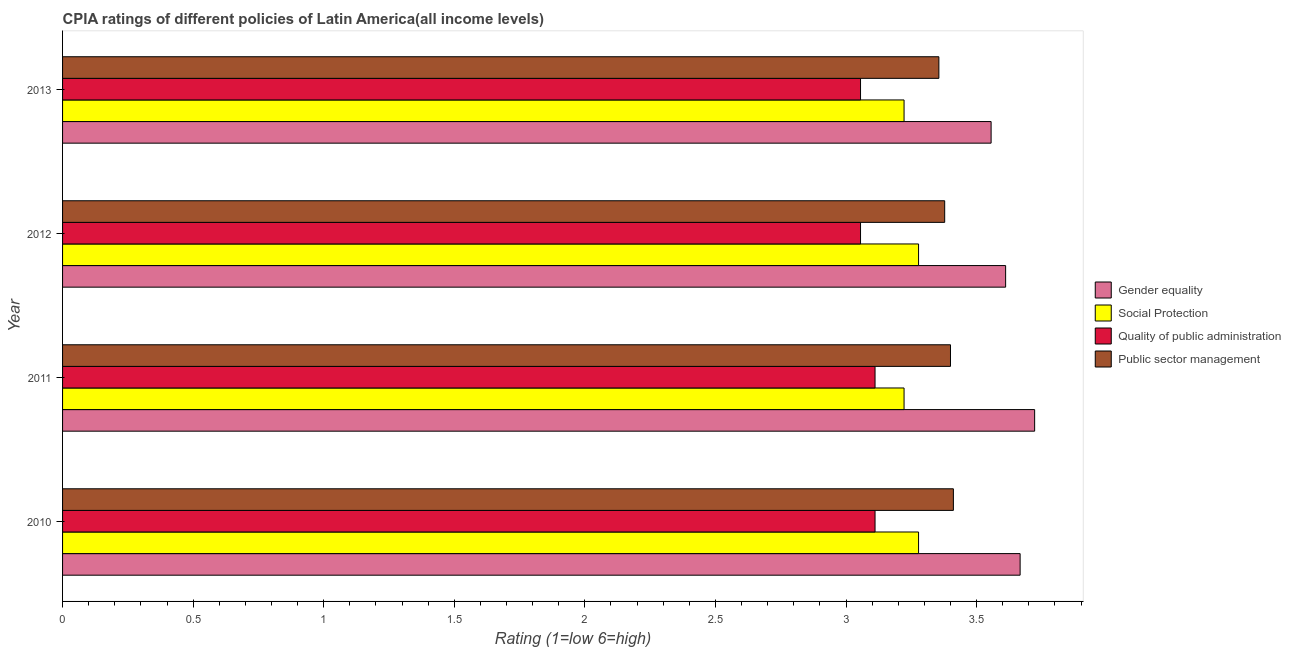How many bars are there on the 3rd tick from the bottom?
Ensure brevity in your answer.  4. What is the cpia rating of social protection in 2012?
Provide a short and direct response. 3.28. Across all years, what is the maximum cpia rating of quality of public administration?
Make the answer very short. 3.11. Across all years, what is the minimum cpia rating of gender equality?
Make the answer very short. 3.56. What is the total cpia rating of public sector management in the graph?
Ensure brevity in your answer.  13.54. What is the difference between the cpia rating of gender equality in 2012 and that in 2013?
Offer a terse response. 0.06. What is the average cpia rating of public sector management per year?
Your answer should be very brief. 3.39. In the year 2012, what is the difference between the cpia rating of quality of public administration and cpia rating of public sector management?
Provide a short and direct response. -0.32. Is the difference between the cpia rating of gender equality in 2010 and 2012 greater than the difference between the cpia rating of social protection in 2010 and 2012?
Ensure brevity in your answer.  Yes. What is the difference between the highest and the lowest cpia rating of social protection?
Make the answer very short. 0.06. Is it the case that in every year, the sum of the cpia rating of social protection and cpia rating of gender equality is greater than the sum of cpia rating of public sector management and cpia rating of quality of public administration?
Give a very brief answer. Yes. What does the 3rd bar from the top in 2013 represents?
Make the answer very short. Social Protection. What does the 1st bar from the bottom in 2013 represents?
Make the answer very short. Gender equality. Is it the case that in every year, the sum of the cpia rating of gender equality and cpia rating of social protection is greater than the cpia rating of quality of public administration?
Give a very brief answer. Yes. Are all the bars in the graph horizontal?
Make the answer very short. Yes. How many years are there in the graph?
Keep it short and to the point. 4. What is the difference between two consecutive major ticks on the X-axis?
Your answer should be very brief. 0.5. Does the graph contain any zero values?
Provide a succinct answer. No. What is the title of the graph?
Your answer should be very brief. CPIA ratings of different policies of Latin America(all income levels). What is the Rating (1=low 6=high) of Gender equality in 2010?
Your answer should be compact. 3.67. What is the Rating (1=low 6=high) in Social Protection in 2010?
Offer a very short reply. 3.28. What is the Rating (1=low 6=high) in Quality of public administration in 2010?
Offer a terse response. 3.11. What is the Rating (1=low 6=high) of Public sector management in 2010?
Make the answer very short. 3.41. What is the Rating (1=low 6=high) in Gender equality in 2011?
Your response must be concise. 3.72. What is the Rating (1=low 6=high) of Social Protection in 2011?
Your answer should be very brief. 3.22. What is the Rating (1=low 6=high) of Quality of public administration in 2011?
Provide a succinct answer. 3.11. What is the Rating (1=low 6=high) in Public sector management in 2011?
Provide a succinct answer. 3.4. What is the Rating (1=low 6=high) of Gender equality in 2012?
Keep it short and to the point. 3.61. What is the Rating (1=low 6=high) in Social Protection in 2012?
Offer a terse response. 3.28. What is the Rating (1=low 6=high) in Quality of public administration in 2012?
Provide a succinct answer. 3.06. What is the Rating (1=low 6=high) in Public sector management in 2012?
Your response must be concise. 3.38. What is the Rating (1=low 6=high) of Gender equality in 2013?
Ensure brevity in your answer.  3.56. What is the Rating (1=low 6=high) in Social Protection in 2013?
Give a very brief answer. 3.22. What is the Rating (1=low 6=high) in Quality of public administration in 2013?
Offer a very short reply. 3.06. What is the Rating (1=low 6=high) of Public sector management in 2013?
Provide a succinct answer. 3.36. Across all years, what is the maximum Rating (1=low 6=high) of Gender equality?
Your answer should be very brief. 3.72. Across all years, what is the maximum Rating (1=low 6=high) of Social Protection?
Offer a terse response. 3.28. Across all years, what is the maximum Rating (1=low 6=high) in Quality of public administration?
Your answer should be very brief. 3.11. Across all years, what is the maximum Rating (1=low 6=high) in Public sector management?
Give a very brief answer. 3.41. Across all years, what is the minimum Rating (1=low 6=high) of Gender equality?
Ensure brevity in your answer.  3.56. Across all years, what is the minimum Rating (1=low 6=high) of Social Protection?
Your response must be concise. 3.22. Across all years, what is the minimum Rating (1=low 6=high) of Quality of public administration?
Your answer should be compact. 3.06. Across all years, what is the minimum Rating (1=low 6=high) in Public sector management?
Your response must be concise. 3.36. What is the total Rating (1=low 6=high) in Gender equality in the graph?
Provide a succinct answer. 14.56. What is the total Rating (1=low 6=high) in Quality of public administration in the graph?
Your response must be concise. 12.33. What is the total Rating (1=low 6=high) in Public sector management in the graph?
Give a very brief answer. 13.54. What is the difference between the Rating (1=low 6=high) in Gender equality in 2010 and that in 2011?
Ensure brevity in your answer.  -0.06. What is the difference between the Rating (1=low 6=high) of Social Protection in 2010 and that in 2011?
Your answer should be compact. 0.06. What is the difference between the Rating (1=low 6=high) of Public sector management in 2010 and that in 2011?
Your answer should be compact. 0.01. What is the difference between the Rating (1=low 6=high) in Gender equality in 2010 and that in 2012?
Your answer should be very brief. 0.06. What is the difference between the Rating (1=low 6=high) of Social Protection in 2010 and that in 2012?
Your answer should be very brief. 0. What is the difference between the Rating (1=low 6=high) of Quality of public administration in 2010 and that in 2012?
Provide a short and direct response. 0.06. What is the difference between the Rating (1=low 6=high) of Public sector management in 2010 and that in 2012?
Your response must be concise. 0.03. What is the difference between the Rating (1=low 6=high) of Social Protection in 2010 and that in 2013?
Your answer should be compact. 0.06. What is the difference between the Rating (1=low 6=high) in Quality of public administration in 2010 and that in 2013?
Ensure brevity in your answer.  0.06. What is the difference between the Rating (1=low 6=high) in Public sector management in 2010 and that in 2013?
Ensure brevity in your answer.  0.06. What is the difference between the Rating (1=low 6=high) of Gender equality in 2011 and that in 2012?
Make the answer very short. 0.11. What is the difference between the Rating (1=low 6=high) in Social Protection in 2011 and that in 2012?
Offer a terse response. -0.06. What is the difference between the Rating (1=low 6=high) of Quality of public administration in 2011 and that in 2012?
Your answer should be compact. 0.06. What is the difference between the Rating (1=low 6=high) in Public sector management in 2011 and that in 2012?
Offer a terse response. 0.02. What is the difference between the Rating (1=low 6=high) of Social Protection in 2011 and that in 2013?
Make the answer very short. 0. What is the difference between the Rating (1=low 6=high) in Quality of public administration in 2011 and that in 2013?
Make the answer very short. 0.06. What is the difference between the Rating (1=low 6=high) of Public sector management in 2011 and that in 2013?
Offer a terse response. 0.04. What is the difference between the Rating (1=low 6=high) of Gender equality in 2012 and that in 2013?
Provide a short and direct response. 0.06. What is the difference between the Rating (1=low 6=high) of Social Protection in 2012 and that in 2013?
Offer a very short reply. 0.06. What is the difference between the Rating (1=low 6=high) of Public sector management in 2012 and that in 2013?
Your answer should be compact. 0.02. What is the difference between the Rating (1=low 6=high) of Gender equality in 2010 and the Rating (1=low 6=high) of Social Protection in 2011?
Provide a succinct answer. 0.44. What is the difference between the Rating (1=low 6=high) of Gender equality in 2010 and the Rating (1=low 6=high) of Quality of public administration in 2011?
Offer a very short reply. 0.56. What is the difference between the Rating (1=low 6=high) of Gender equality in 2010 and the Rating (1=low 6=high) of Public sector management in 2011?
Your answer should be very brief. 0.27. What is the difference between the Rating (1=low 6=high) of Social Protection in 2010 and the Rating (1=low 6=high) of Public sector management in 2011?
Offer a very short reply. -0.12. What is the difference between the Rating (1=low 6=high) of Quality of public administration in 2010 and the Rating (1=low 6=high) of Public sector management in 2011?
Offer a very short reply. -0.29. What is the difference between the Rating (1=low 6=high) of Gender equality in 2010 and the Rating (1=low 6=high) of Social Protection in 2012?
Your answer should be compact. 0.39. What is the difference between the Rating (1=low 6=high) in Gender equality in 2010 and the Rating (1=low 6=high) in Quality of public administration in 2012?
Your response must be concise. 0.61. What is the difference between the Rating (1=low 6=high) of Gender equality in 2010 and the Rating (1=low 6=high) of Public sector management in 2012?
Provide a short and direct response. 0.29. What is the difference between the Rating (1=low 6=high) of Social Protection in 2010 and the Rating (1=low 6=high) of Quality of public administration in 2012?
Your response must be concise. 0.22. What is the difference between the Rating (1=low 6=high) of Social Protection in 2010 and the Rating (1=low 6=high) of Public sector management in 2012?
Make the answer very short. -0.1. What is the difference between the Rating (1=low 6=high) in Quality of public administration in 2010 and the Rating (1=low 6=high) in Public sector management in 2012?
Provide a succinct answer. -0.27. What is the difference between the Rating (1=low 6=high) in Gender equality in 2010 and the Rating (1=low 6=high) in Social Protection in 2013?
Your answer should be very brief. 0.44. What is the difference between the Rating (1=low 6=high) in Gender equality in 2010 and the Rating (1=low 6=high) in Quality of public administration in 2013?
Your answer should be compact. 0.61. What is the difference between the Rating (1=low 6=high) of Gender equality in 2010 and the Rating (1=low 6=high) of Public sector management in 2013?
Keep it short and to the point. 0.31. What is the difference between the Rating (1=low 6=high) in Social Protection in 2010 and the Rating (1=low 6=high) in Quality of public administration in 2013?
Offer a very short reply. 0.22. What is the difference between the Rating (1=low 6=high) in Social Protection in 2010 and the Rating (1=low 6=high) in Public sector management in 2013?
Provide a short and direct response. -0.08. What is the difference between the Rating (1=low 6=high) in Quality of public administration in 2010 and the Rating (1=low 6=high) in Public sector management in 2013?
Provide a succinct answer. -0.24. What is the difference between the Rating (1=low 6=high) in Gender equality in 2011 and the Rating (1=low 6=high) in Social Protection in 2012?
Provide a short and direct response. 0.44. What is the difference between the Rating (1=low 6=high) in Gender equality in 2011 and the Rating (1=low 6=high) in Quality of public administration in 2012?
Offer a very short reply. 0.67. What is the difference between the Rating (1=low 6=high) of Gender equality in 2011 and the Rating (1=low 6=high) of Public sector management in 2012?
Give a very brief answer. 0.34. What is the difference between the Rating (1=low 6=high) of Social Protection in 2011 and the Rating (1=low 6=high) of Quality of public administration in 2012?
Provide a short and direct response. 0.17. What is the difference between the Rating (1=low 6=high) in Social Protection in 2011 and the Rating (1=low 6=high) in Public sector management in 2012?
Ensure brevity in your answer.  -0.16. What is the difference between the Rating (1=low 6=high) in Quality of public administration in 2011 and the Rating (1=low 6=high) in Public sector management in 2012?
Provide a short and direct response. -0.27. What is the difference between the Rating (1=low 6=high) of Gender equality in 2011 and the Rating (1=low 6=high) of Social Protection in 2013?
Offer a terse response. 0.5. What is the difference between the Rating (1=low 6=high) of Gender equality in 2011 and the Rating (1=low 6=high) of Public sector management in 2013?
Offer a very short reply. 0.37. What is the difference between the Rating (1=low 6=high) of Social Protection in 2011 and the Rating (1=low 6=high) of Quality of public administration in 2013?
Ensure brevity in your answer.  0.17. What is the difference between the Rating (1=low 6=high) of Social Protection in 2011 and the Rating (1=low 6=high) of Public sector management in 2013?
Provide a short and direct response. -0.13. What is the difference between the Rating (1=low 6=high) in Quality of public administration in 2011 and the Rating (1=low 6=high) in Public sector management in 2013?
Ensure brevity in your answer.  -0.24. What is the difference between the Rating (1=low 6=high) in Gender equality in 2012 and the Rating (1=low 6=high) in Social Protection in 2013?
Keep it short and to the point. 0.39. What is the difference between the Rating (1=low 6=high) of Gender equality in 2012 and the Rating (1=low 6=high) of Quality of public administration in 2013?
Make the answer very short. 0.56. What is the difference between the Rating (1=low 6=high) in Gender equality in 2012 and the Rating (1=low 6=high) in Public sector management in 2013?
Your answer should be very brief. 0.26. What is the difference between the Rating (1=low 6=high) of Social Protection in 2012 and the Rating (1=low 6=high) of Quality of public administration in 2013?
Provide a short and direct response. 0.22. What is the difference between the Rating (1=low 6=high) of Social Protection in 2012 and the Rating (1=low 6=high) of Public sector management in 2013?
Your answer should be very brief. -0.08. What is the difference between the Rating (1=low 6=high) of Quality of public administration in 2012 and the Rating (1=low 6=high) of Public sector management in 2013?
Offer a terse response. -0.3. What is the average Rating (1=low 6=high) in Gender equality per year?
Offer a terse response. 3.64. What is the average Rating (1=low 6=high) in Quality of public administration per year?
Give a very brief answer. 3.08. What is the average Rating (1=low 6=high) of Public sector management per year?
Make the answer very short. 3.39. In the year 2010, what is the difference between the Rating (1=low 6=high) of Gender equality and Rating (1=low 6=high) of Social Protection?
Your response must be concise. 0.39. In the year 2010, what is the difference between the Rating (1=low 6=high) in Gender equality and Rating (1=low 6=high) in Quality of public administration?
Provide a succinct answer. 0.56. In the year 2010, what is the difference between the Rating (1=low 6=high) of Gender equality and Rating (1=low 6=high) of Public sector management?
Provide a succinct answer. 0.26. In the year 2010, what is the difference between the Rating (1=low 6=high) of Social Protection and Rating (1=low 6=high) of Public sector management?
Your answer should be very brief. -0.13. In the year 2010, what is the difference between the Rating (1=low 6=high) of Quality of public administration and Rating (1=low 6=high) of Public sector management?
Keep it short and to the point. -0.3. In the year 2011, what is the difference between the Rating (1=low 6=high) of Gender equality and Rating (1=low 6=high) of Quality of public administration?
Offer a very short reply. 0.61. In the year 2011, what is the difference between the Rating (1=low 6=high) in Gender equality and Rating (1=low 6=high) in Public sector management?
Give a very brief answer. 0.32. In the year 2011, what is the difference between the Rating (1=low 6=high) in Social Protection and Rating (1=low 6=high) in Quality of public administration?
Offer a terse response. 0.11. In the year 2011, what is the difference between the Rating (1=low 6=high) of Social Protection and Rating (1=low 6=high) of Public sector management?
Provide a succinct answer. -0.18. In the year 2011, what is the difference between the Rating (1=low 6=high) of Quality of public administration and Rating (1=low 6=high) of Public sector management?
Give a very brief answer. -0.29. In the year 2012, what is the difference between the Rating (1=low 6=high) in Gender equality and Rating (1=low 6=high) in Quality of public administration?
Your response must be concise. 0.56. In the year 2012, what is the difference between the Rating (1=low 6=high) of Gender equality and Rating (1=low 6=high) of Public sector management?
Offer a very short reply. 0.23. In the year 2012, what is the difference between the Rating (1=low 6=high) of Social Protection and Rating (1=low 6=high) of Quality of public administration?
Offer a very short reply. 0.22. In the year 2012, what is the difference between the Rating (1=low 6=high) in Quality of public administration and Rating (1=low 6=high) in Public sector management?
Your answer should be compact. -0.32. In the year 2013, what is the difference between the Rating (1=low 6=high) of Gender equality and Rating (1=low 6=high) of Quality of public administration?
Make the answer very short. 0.5. In the year 2013, what is the difference between the Rating (1=low 6=high) in Gender equality and Rating (1=low 6=high) in Public sector management?
Provide a succinct answer. 0.2. In the year 2013, what is the difference between the Rating (1=low 6=high) of Social Protection and Rating (1=low 6=high) of Quality of public administration?
Your response must be concise. 0.17. In the year 2013, what is the difference between the Rating (1=low 6=high) in Social Protection and Rating (1=low 6=high) in Public sector management?
Make the answer very short. -0.13. What is the ratio of the Rating (1=low 6=high) of Gender equality in 2010 to that in 2011?
Keep it short and to the point. 0.99. What is the ratio of the Rating (1=low 6=high) in Social Protection in 2010 to that in 2011?
Provide a short and direct response. 1.02. What is the ratio of the Rating (1=low 6=high) of Gender equality in 2010 to that in 2012?
Provide a succinct answer. 1.02. What is the ratio of the Rating (1=low 6=high) in Social Protection in 2010 to that in 2012?
Give a very brief answer. 1. What is the ratio of the Rating (1=low 6=high) in Quality of public administration in 2010 to that in 2012?
Your answer should be compact. 1.02. What is the ratio of the Rating (1=low 6=high) in Public sector management in 2010 to that in 2012?
Provide a succinct answer. 1.01. What is the ratio of the Rating (1=low 6=high) in Gender equality in 2010 to that in 2013?
Keep it short and to the point. 1.03. What is the ratio of the Rating (1=low 6=high) in Social Protection in 2010 to that in 2013?
Offer a terse response. 1.02. What is the ratio of the Rating (1=low 6=high) of Quality of public administration in 2010 to that in 2013?
Your answer should be very brief. 1.02. What is the ratio of the Rating (1=low 6=high) in Public sector management in 2010 to that in 2013?
Your answer should be compact. 1.02. What is the ratio of the Rating (1=low 6=high) of Gender equality in 2011 to that in 2012?
Your response must be concise. 1.03. What is the ratio of the Rating (1=low 6=high) in Social Protection in 2011 to that in 2012?
Keep it short and to the point. 0.98. What is the ratio of the Rating (1=low 6=high) of Quality of public administration in 2011 to that in 2012?
Provide a short and direct response. 1.02. What is the ratio of the Rating (1=low 6=high) of Public sector management in 2011 to that in 2012?
Keep it short and to the point. 1.01. What is the ratio of the Rating (1=low 6=high) in Gender equality in 2011 to that in 2013?
Give a very brief answer. 1.05. What is the ratio of the Rating (1=low 6=high) of Social Protection in 2011 to that in 2013?
Give a very brief answer. 1. What is the ratio of the Rating (1=low 6=high) in Quality of public administration in 2011 to that in 2013?
Keep it short and to the point. 1.02. What is the ratio of the Rating (1=low 6=high) in Public sector management in 2011 to that in 2013?
Ensure brevity in your answer.  1.01. What is the ratio of the Rating (1=low 6=high) in Gender equality in 2012 to that in 2013?
Keep it short and to the point. 1.02. What is the ratio of the Rating (1=low 6=high) in Social Protection in 2012 to that in 2013?
Ensure brevity in your answer.  1.02. What is the ratio of the Rating (1=low 6=high) of Public sector management in 2012 to that in 2013?
Your answer should be compact. 1.01. What is the difference between the highest and the second highest Rating (1=low 6=high) in Gender equality?
Your answer should be compact. 0.06. What is the difference between the highest and the second highest Rating (1=low 6=high) in Social Protection?
Make the answer very short. 0. What is the difference between the highest and the second highest Rating (1=low 6=high) in Quality of public administration?
Offer a very short reply. 0. What is the difference between the highest and the second highest Rating (1=low 6=high) in Public sector management?
Offer a terse response. 0.01. What is the difference between the highest and the lowest Rating (1=low 6=high) of Social Protection?
Keep it short and to the point. 0.06. What is the difference between the highest and the lowest Rating (1=low 6=high) in Quality of public administration?
Provide a short and direct response. 0.06. What is the difference between the highest and the lowest Rating (1=low 6=high) in Public sector management?
Your answer should be very brief. 0.06. 